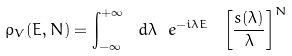Convert formula to latex. <formula><loc_0><loc_0><loc_500><loc_500>\rho _ { V } ( E , N ) = \int _ { - \infty } ^ { + \infty } \ d \lambda \ e ^ { - i \lambda E } \ \left [ { \frac { s ( \lambda ) } { \lambda } } \right ] ^ { N }</formula> 